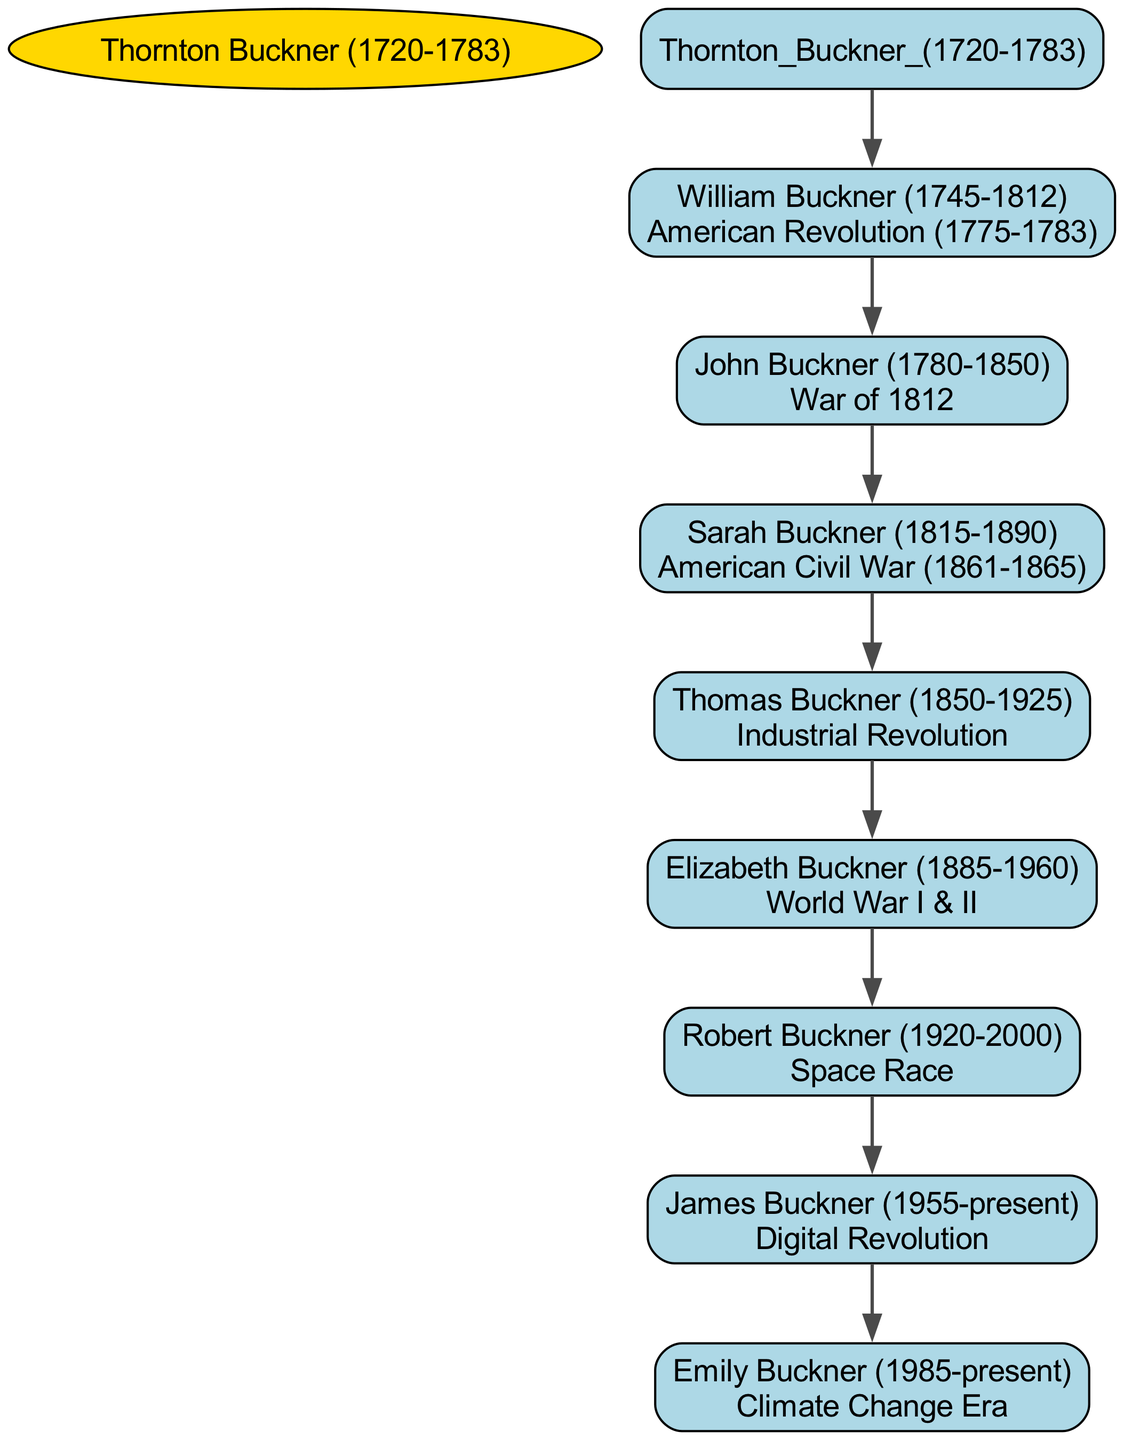How many generations are shown in the family tree? The tree starts with Thornton Buckner and follows down to Emily Buckner, showing 6 generations: Thornton, William, John, Sarah, Thomas, Elizabeth, Robert, James, and Emily. Thus, there are 6 generations in total.
Answer: 6 Who fought in the War of 1812? The tree shows that John Buckner, born in 1780 and died in 1850, is connected with the War of 1812. The diagram lists his name directly under the event.
Answer: John Buckner Which event is associated with Elizabeth Buckner? Elizabeth Buckner is associated with both World War I and II, as indicated under her name in the diagram. This historical context is directly linked with her lineage.
Answer: World War I & II What significant historical event occurred during Thornton Buckner's lifetime? The American Revolution occurred between 1775 and 1783, a major historical event that overlaps with Thornton Buckner's lifetime as he was born in 1720 and died in 1783.
Answer: American Revolution How many children did William Buckner have? William Buckner has one child listed in the diagram: John Buckner, directly connected under his name. The family tree shows only John as a descendant.
Answer: 1 Who is the direct descendant of Robert Buckner? The diagram connects Robert Buckner to James Buckner as his direct descendant; thus, James is the child of Robert in the family lineage.
Answer: James Buckner Which event follows the Industrial Revolution in the family tree? The diagram places the American Civil War right above the Industrial Revolution, which connects Sarah Buckner to Thomas Buckner, who lived during the Industrial Revolution era.
Answer: American Civil War What is the birth year of Emily Buckner? Emily Buckner is born in 1985 according to the details shown by her name in the family tree diagram, where her birth year is clearly stated.
Answer: 1985 Which event is associated with James Buckner's life? James Buckner's life is closely linked to the Digital Revolution, which is noted directly under his name and reflects his generational influence regarding technology.
Answer: Digital Revolution 